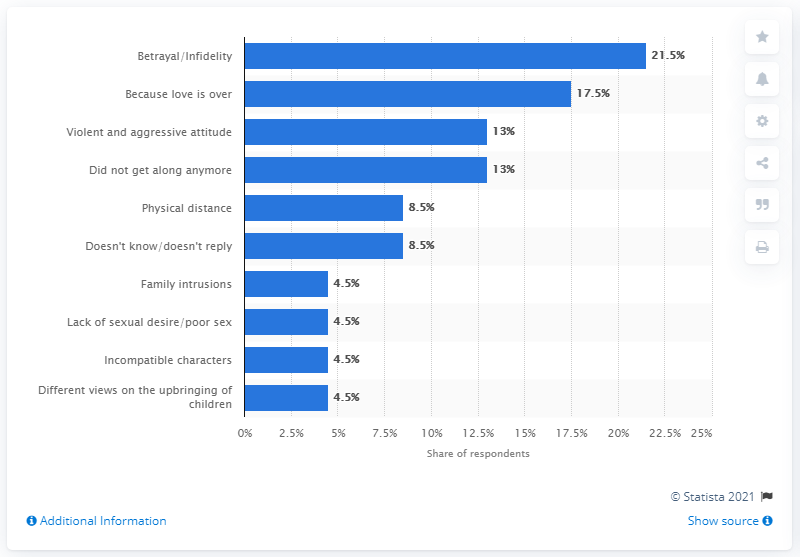Outline some significant characteristics in this image. According to the survey, 17.5% of Italians said that the love between their spouses had come to an end. 